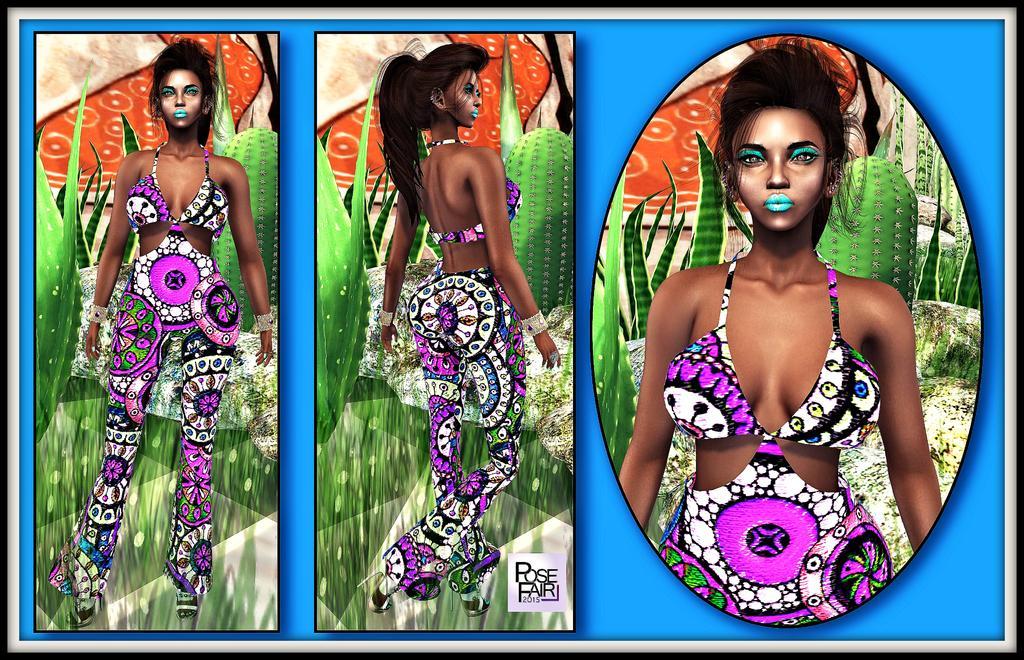Can you describe this image briefly? In this picture there are posters in the image. 